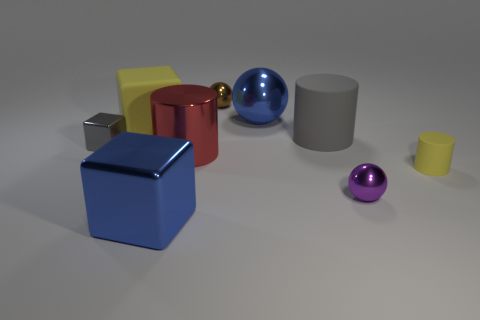Are there more shiny objects to the left of the small gray metallic block than tiny things to the right of the big blue ball?
Give a very brief answer. No. There is a blue metal thing that is behind the big metal block to the left of the tiny ball in front of the large rubber cube; what size is it?
Provide a succinct answer. Large. Are there any large metal cylinders of the same color as the small cylinder?
Provide a short and direct response. No. How many small spheres are there?
Offer a terse response. 2. What is the material of the large blue thing behind the large blue metallic object on the left side of the blue thing behind the large red metallic cylinder?
Provide a succinct answer. Metal. Is there a red thing made of the same material as the small brown thing?
Provide a succinct answer. Yes. Do the small brown sphere and the large red cylinder have the same material?
Offer a very short reply. Yes. How many cylinders are either tiny purple shiny objects or small brown shiny things?
Provide a short and direct response. 0. The tiny block that is made of the same material as the large blue sphere is what color?
Your answer should be very brief. Gray. Are there fewer blue metallic balls than tiny gray matte things?
Provide a short and direct response. No. 